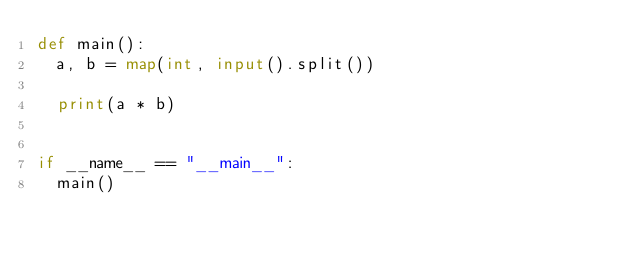<code> <loc_0><loc_0><loc_500><loc_500><_Python_>def main():
  a, b = map(int, input().split())

  print(a * b)


if __name__ == "__main__":
  main()
</code> 